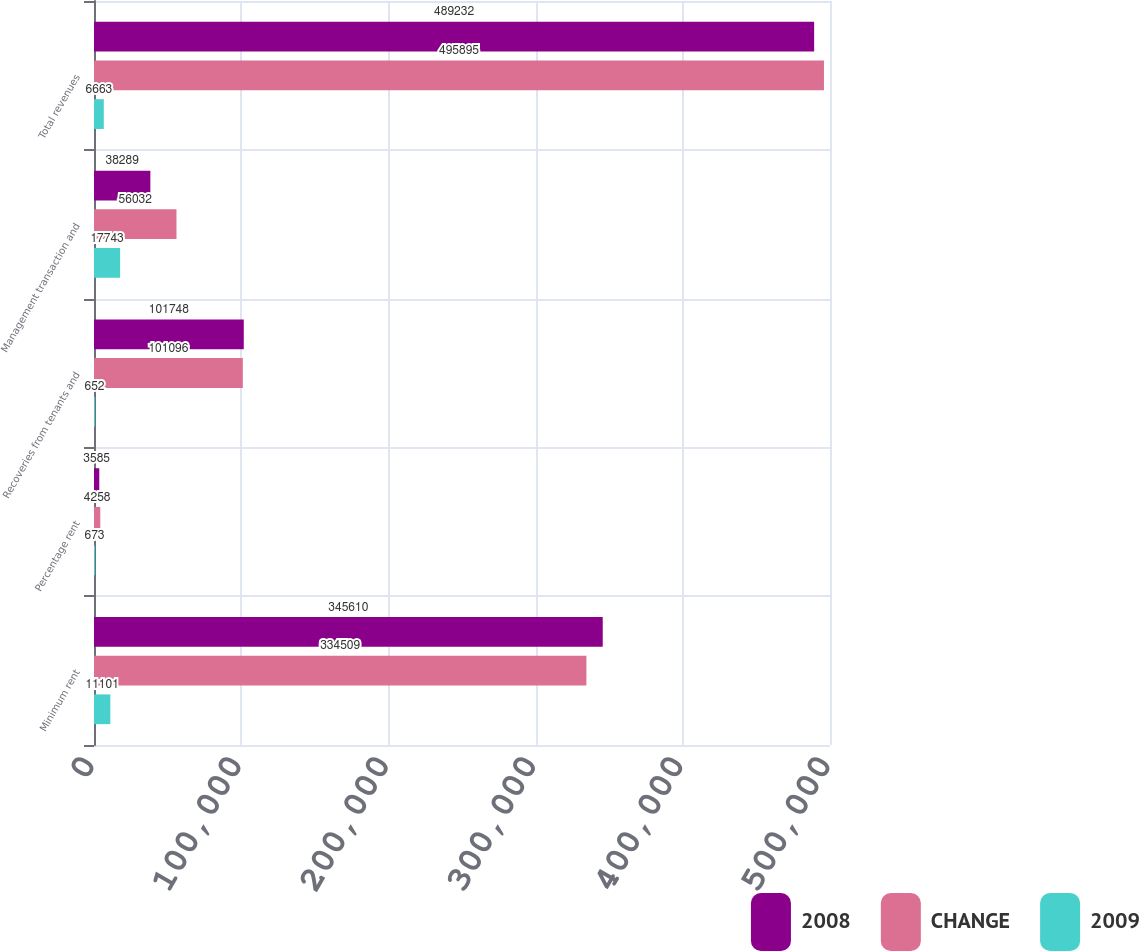<chart> <loc_0><loc_0><loc_500><loc_500><stacked_bar_chart><ecel><fcel>Minimum rent<fcel>Percentage rent<fcel>Recoveries from tenants and<fcel>Management transaction and<fcel>Total revenues<nl><fcel>2008<fcel>345610<fcel>3585<fcel>101748<fcel>38289<fcel>489232<nl><fcel>CHANGE<fcel>334509<fcel>4258<fcel>101096<fcel>56032<fcel>495895<nl><fcel>2009<fcel>11101<fcel>673<fcel>652<fcel>17743<fcel>6663<nl></chart> 